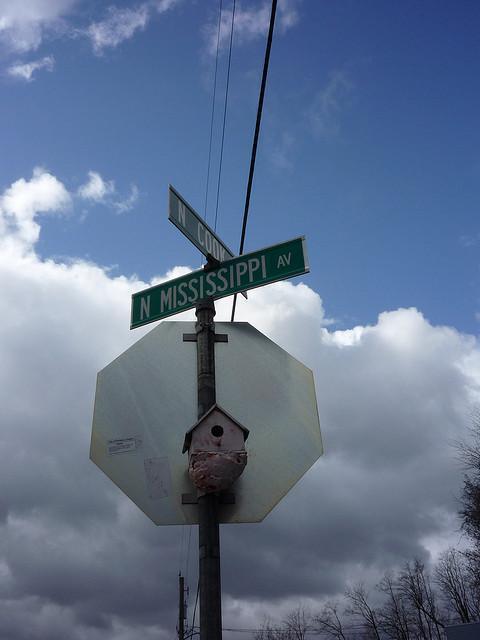How many people are wearing purple headbands?
Give a very brief answer. 0. 